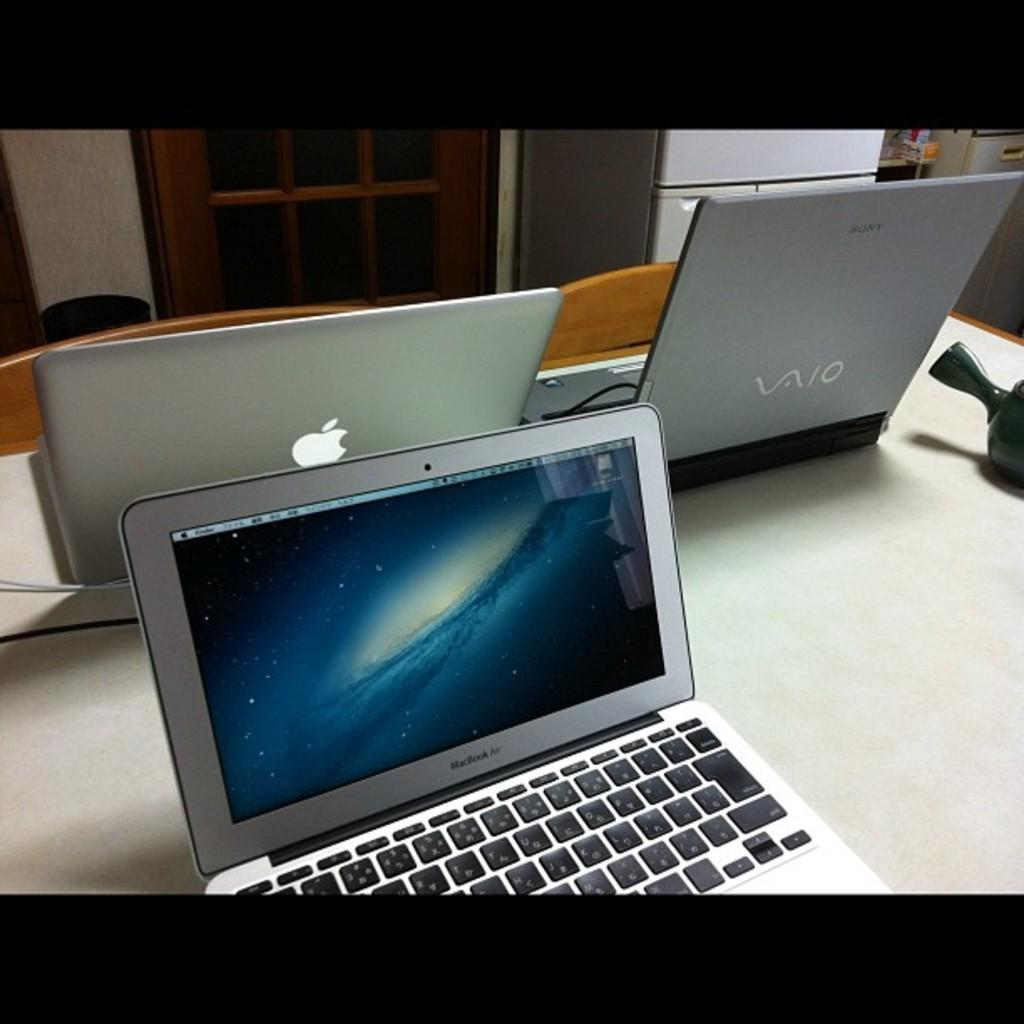<image>
Relay a brief, clear account of the picture shown. An apple laptop is sitting next to a vaio laptop. 